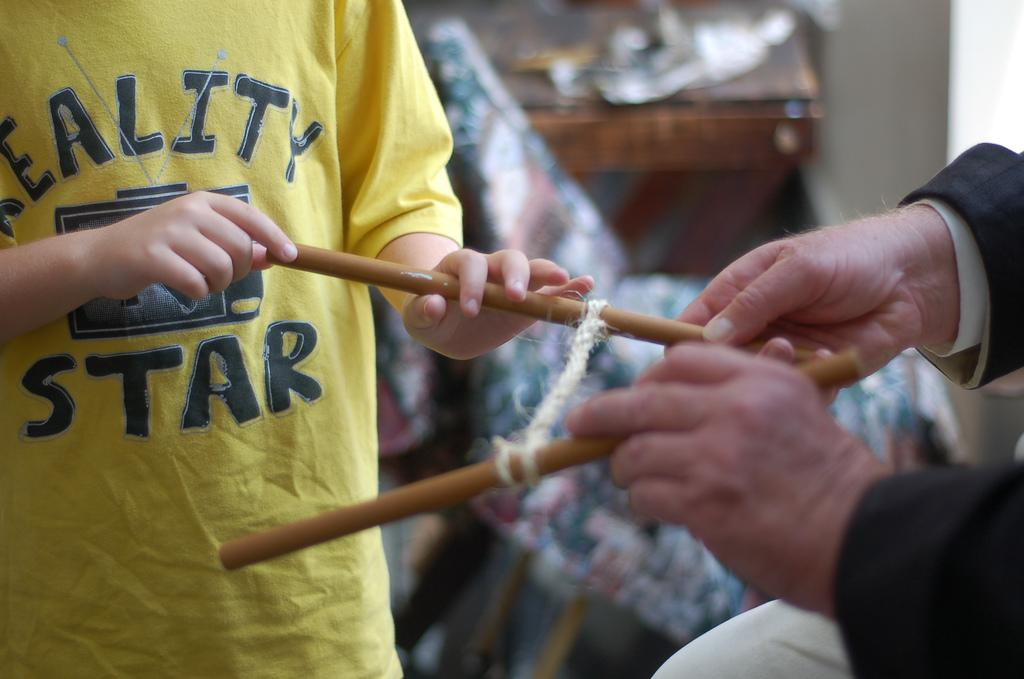<image>
Present a compact description of the photo's key features. a person with a yellow shirt that says the word STAR on it 